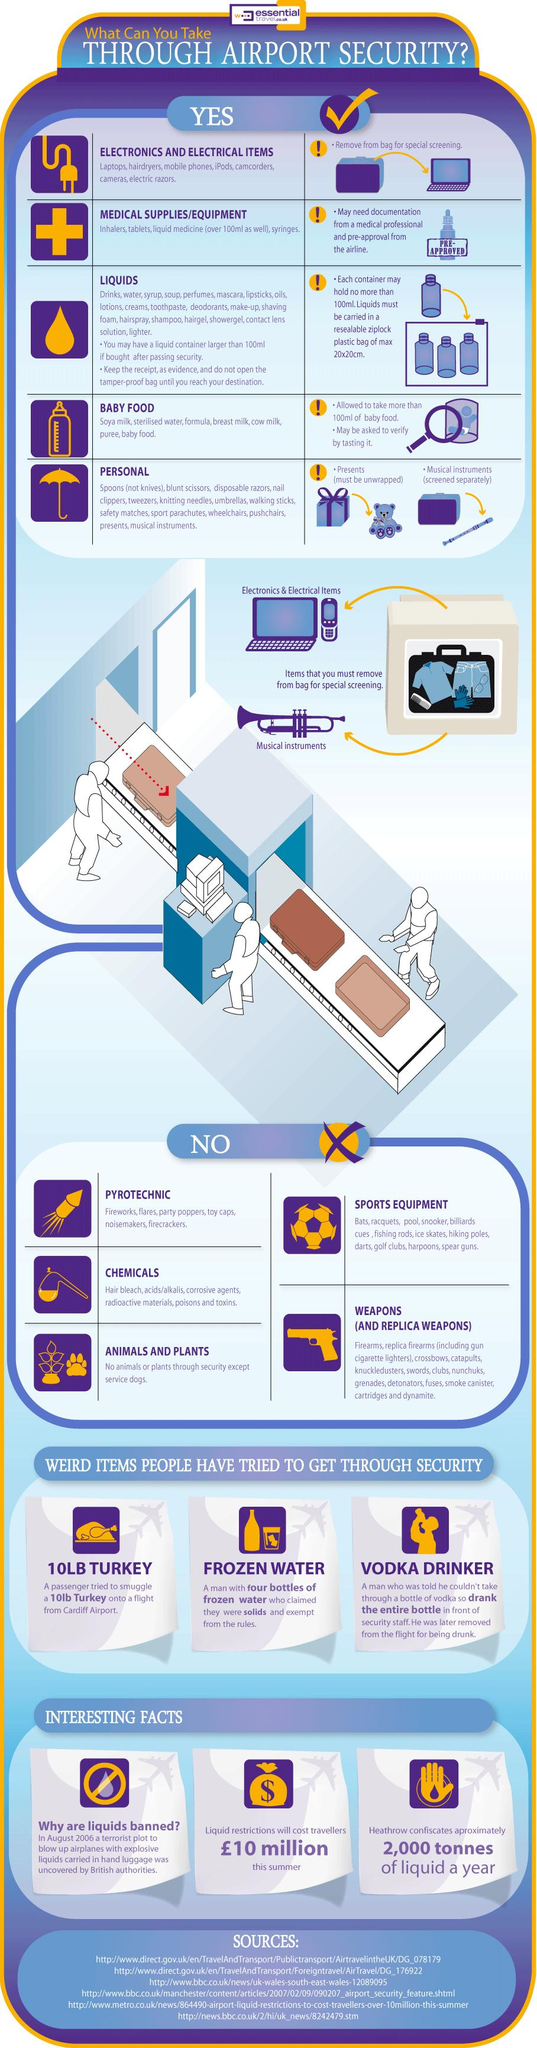Highlight a few significant elements in this photo. It is permissible to take up to 5 items through airport security. During special screening, it is recommended that two items be removed from the bag. Medical supplies and equipment may need to be verified with prescriptions from doctors at airport security. 